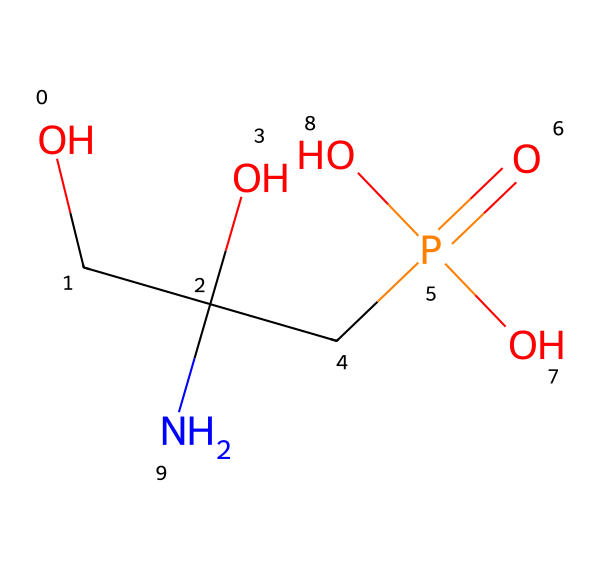What is the molecular formula of this herbicide? The SMILES representation can be converted to the molecular formula by identifying each atom and their quantities. In this SMILES: C, H, N, O, and P are present in specific counts: 3 Carbon (C), 9 Hydrogen (H), 1 Nitrogen (N), 4 Oxygen (O), and 1 Phosphorus (P) are derived from analyzing the structure. The overall molecular formula is C3H8NO5P.
Answer: C3H8NO5P How many oxygen atoms are present in this molecule? By counting the "O" characters in the SMILES, we can see there are four "O" present in the structure. This indicates there are four oxygen atoms in the herbicide.
Answer: 4 What functional groups can be identified in this herbicide? Analyzing the SMILES shows several functional groups: a phosphonic acid (due to the P(=O)(O)O part), alcohol (OCC with a carbon bond), and an amine group (N), which are all characteristic structures found in the compound.
Answer: phosphonic acid, alcohol, amine Does this chemical contain phosphorus? The presence of the "P" in the SMILES indicates that phosphorus is indeed present in the molecular structure of the herbicide.
Answer: Yes What type of herbicide is glyphosate primarily classified as? Glyphosate is primarily classified as a systemic herbicide, targeting the shikimic acid pathway in plants, which is inferred from its chemical structure being a broad-spectrum herbicide used in agricultural settings.
Answer: systemic How does the presence of nitrogen affect the performance of this herbicide? The nitrogen atom in glyphosate suggests an amino acid structure, enhancing its absorption and mobility in plants. This structural feature allows glyphosate to disrupt specific metabolic pathways, increasing its effectiveness against weeds.
Answer: enhances absorption and mobility What is the primary role of glyphosate in agriculture? Glyphosate is commonly used as an herbicide to control broadleaf weeds and grasses by inhibiting a specific enzyme pathway. This is deduced from its function and the nature of its molecular structure, which targets plant processes.
Answer: weed control 